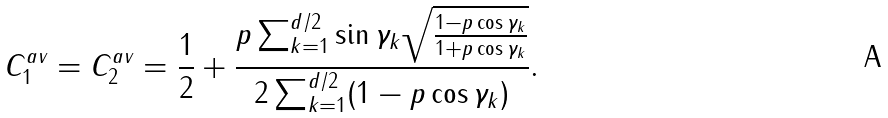Convert formula to latex. <formula><loc_0><loc_0><loc_500><loc_500>C _ { 1 } ^ { a v } = C _ { 2 } ^ { a v } = \frac { 1 } { 2 } + \frac { p \sum _ { k = 1 } ^ { d / 2 } \sin \gamma _ { k } \sqrt { \frac { 1 - p \cos \gamma _ { k } } { 1 + p \cos \gamma _ { k } } } } { 2 \sum _ { k = 1 } ^ { d / 2 } ( 1 - p \cos \gamma _ { k } ) } .</formula> 